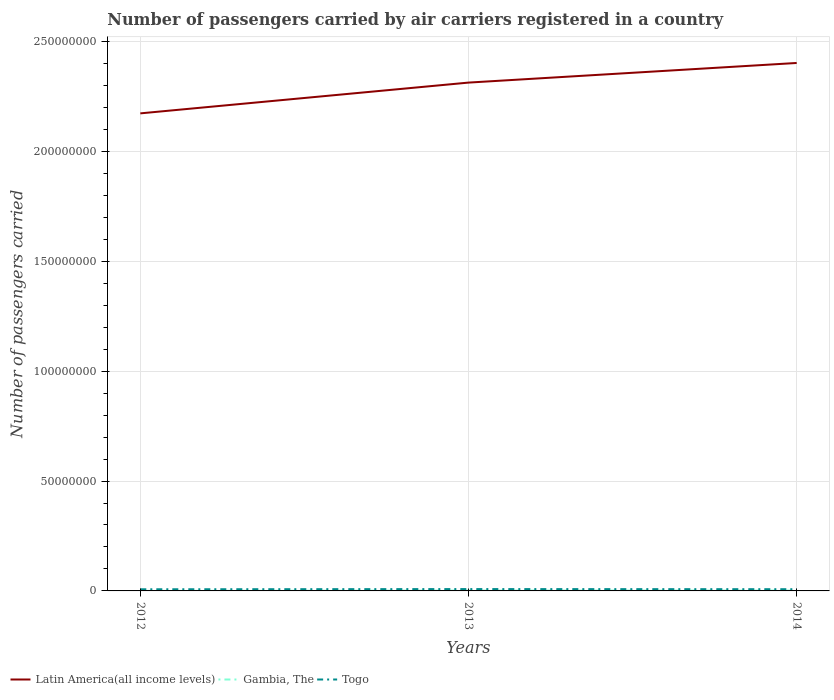How many different coloured lines are there?
Offer a very short reply. 3. Does the line corresponding to Togo intersect with the line corresponding to Gambia, The?
Your answer should be compact. No. Is the number of lines equal to the number of legend labels?
Keep it short and to the point. Yes. Across all years, what is the maximum number of passengers carried by air carriers in Latin America(all income levels)?
Ensure brevity in your answer.  2.17e+08. What is the total number of passengers carried by air carriers in Latin America(all income levels) in the graph?
Provide a succinct answer. -1.40e+07. What is the difference between the highest and the second highest number of passengers carried by air carriers in Togo?
Your response must be concise. 9.52e+04. What is the difference between the highest and the lowest number of passengers carried by air carriers in Gambia, The?
Your answer should be very brief. 2. Is the number of passengers carried by air carriers in Gambia, The strictly greater than the number of passengers carried by air carriers in Togo over the years?
Keep it short and to the point. Yes. How many years are there in the graph?
Make the answer very short. 3. What is the difference between two consecutive major ticks on the Y-axis?
Make the answer very short. 5.00e+07. Are the values on the major ticks of Y-axis written in scientific E-notation?
Ensure brevity in your answer.  No. Where does the legend appear in the graph?
Offer a very short reply. Bottom left. How many legend labels are there?
Make the answer very short. 3. What is the title of the graph?
Make the answer very short. Number of passengers carried by air carriers registered in a country. What is the label or title of the X-axis?
Your response must be concise. Years. What is the label or title of the Y-axis?
Ensure brevity in your answer.  Number of passengers carried. What is the Number of passengers carried of Latin America(all income levels) in 2012?
Your answer should be very brief. 2.17e+08. What is the Number of passengers carried of Gambia, The in 2012?
Give a very brief answer. 1.13e+04. What is the Number of passengers carried of Togo in 2012?
Provide a succinct answer. 7.46e+05. What is the Number of passengers carried in Latin America(all income levels) in 2013?
Your answer should be compact. 2.31e+08. What is the Number of passengers carried of Gambia, The in 2013?
Your answer should be very brief. 1.47e+05. What is the Number of passengers carried in Togo in 2013?
Provide a succinct answer. 8.41e+05. What is the Number of passengers carried of Latin America(all income levels) in 2014?
Give a very brief answer. 2.40e+08. What is the Number of passengers carried in Gambia, The in 2014?
Make the answer very short. 1.52e+05. What is the Number of passengers carried in Togo in 2014?
Offer a terse response. 7.79e+05. Across all years, what is the maximum Number of passengers carried in Latin America(all income levels)?
Your answer should be very brief. 2.40e+08. Across all years, what is the maximum Number of passengers carried of Gambia, The?
Your answer should be very brief. 1.52e+05. Across all years, what is the maximum Number of passengers carried of Togo?
Your answer should be compact. 8.41e+05. Across all years, what is the minimum Number of passengers carried of Latin America(all income levels)?
Offer a terse response. 2.17e+08. Across all years, what is the minimum Number of passengers carried in Gambia, The?
Make the answer very short. 1.13e+04. Across all years, what is the minimum Number of passengers carried in Togo?
Keep it short and to the point. 7.46e+05. What is the total Number of passengers carried of Latin America(all income levels) in the graph?
Make the answer very short. 6.89e+08. What is the total Number of passengers carried of Gambia, The in the graph?
Provide a succinct answer. 3.10e+05. What is the total Number of passengers carried of Togo in the graph?
Ensure brevity in your answer.  2.37e+06. What is the difference between the Number of passengers carried in Latin America(all income levels) in 2012 and that in 2013?
Your answer should be very brief. -1.40e+07. What is the difference between the Number of passengers carried of Gambia, The in 2012 and that in 2013?
Your response must be concise. -1.36e+05. What is the difference between the Number of passengers carried in Togo in 2012 and that in 2013?
Your response must be concise. -9.52e+04. What is the difference between the Number of passengers carried in Latin America(all income levels) in 2012 and that in 2014?
Your response must be concise. -2.29e+07. What is the difference between the Number of passengers carried of Gambia, The in 2012 and that in 2014?
Your answer should be very brief. -1.40e+05. What is the difference between the Number of passengers carried in Togo in 2012 and that in 2014?
Your answer should be compact. -3.35e+04. What is the difference between the Number of passengers carried of Latin America(all income levels) in 2013 and that in 2014?
Your response must be concise. -8.93e+06. What is the difference between the Number of passengers carried of Gambia, The in 2013 and that in 2014?
Keep it short and to the point. -4990.75. What is the difference between the Number of passengers carried of Togo in 2013 and that in 2014?
Ensure brevity in your answer.  6.17e+04. What is the difference between the Number of passengers carried in Latin America(all income levels) in 2012 and the Number of passengers carried in Gambia, The in 2013?
Provide a succinct answer. 2.17e+08. What is the difference between the Number of passengers carried of Latin America(all income levels) in 2012 and the Number of passengers carried of Togo in 2013?
Your answer should be very brief. 2.16e+08. What is the difference between the Number of passengers carried of Gambia, The in 2012 and the Number of passengers carried of Togo in 2013?
Offer a very short reply. -8.30e+05. What is the difference between the Number of passengers carried in Latin America(all income levels) in 2012 and the Number of passengers carried in Gambia, The in 2014?
Your answer should be compact. 2.17e+08. What is the difference between the Number of passengers carried in Latin America(all income levels) in 2012 and the Number of passengers carried in Togo in 2014?
Provide a short and direct response. 2.17e+08. What is the difference between the Number of passengers carried of Gambia, The in 2012 and the Number of passengers carried of Togo in 2014?
Give a very brief answer. -7.68e+05. What is the difference between the Number of passengers carried of Latin America(all income levels) in 2013 and the Number of passengers carried of Gambia, The in 2014?
Ensure brevity in your answer.  2.31e+08. What is the difference between the Number of passengers carried in Latin America(all income levels) in 2013 and the Number of passengers carried in Togo in 2014?
Keep it short and to the point. 2.31e+08. What is the difference between the Number of passengers carried of Gambia, The in 2013 and the Number of passengers carried of Togo in 2014?
Provide a short and direct response. -6.32e+05. What is the average Number of passengers carried of Latin America(all income levels) per year?
Your answer should be compact. 2.30e+08. What is the average Number of passengers carried in Gambia, The per year?
Make the answer very short. 1.03e+05. What is the average Number of passengers carried of Togo per year?
Offer a terse response. 7.89e+05. In the year 2012, what is the difference between the Number of passengers carried of Latin America(all income levels) and Number of passengers carried of Gambia, The?
Provide a succinct answer. 2.17e+08. In the year 2012, what is the difference between the Number of passengers carried of Latin America(all income levels) and Number of passengers carried of Togo?
Your answer should be very brief. 2.17e+08. In the year 2012, what is the difference between the Number of passengers carried of Gambia, The and Number of passengers carried of Togo?
Offer a very short reply. -7.34e+05. In the year 2013, what is the difference between the Number of passengers carried of Latin America(all income levels) and Number of passengers carried of Gambia, The?
Make the answer very short. 2.31e+08. In the year 2013, what is the difference between the Number of passengers carried in Latin America(all income levels) and Number of passengers carried in Togo?
Offer a very short reply. 2.30e+08. In the year 2013, what is the difference between the Number of passengers carried of Gambia, The and Number of passengers carried of Togo?
Your answer should be compact. -6.94e+05. In the year 2014, what is the difference between the Number of passengers carried of Latin America(all income levels) and Number of passengers carried of Gambia, The?
Provide a short and direct response. 2.40e+08. In the year 2014, what is the difference between the Number of passengers carried of Latin America(all income levels) and Number of passengers carried of Togo?
Your answer should be very brief. 2.39e+08. In the year 2014, what is the difference between the Number of passengers carried in Gambia, The and Number of passengers carried in Togo?
Your response must be concise. -6.27e+05. What is the ratio of the Number of passengers carried in Latin America(all income levels) in 2012 to that in 2013?
Offer a very short reply. 0.94. What is the ratio of the Number of passengers carried of Gambia, The in 2012 to that in 2013?
Your answer should be very brief. 0.08. What is the ratio of the Number of passengers carried in Togo in 2012 to that in 2013?
Provide a succinct answer. 0.89. What is the ratio of the Number of passengers carried of Latin America(all income levels) in 2012 to that in 2014?
Give a very brief answer. 0.9. What is the ratio of the Number of passengers carried of Gambia, The in 2012 to that in 2014?
Keep it short and to the point. 0.07. What is the ratio of the Number of passengers carried of Togo in 2012 to that in 2014?
Provide a succinct answer. 0.96. What is the ratio of the Number of passengers carried in Latin America(all income levels) in 2013 to that in 2014?
Make the answer very short. 0.96. What is the ratio of the Number of passengers carried in Gambia, The in 2013 to that in 2014?
Your response must be concise. 0.97. What is the ratio of the Number of passengers carried in Togo in 2013 to that in 2014?
Ensure brevity in your answer.  1.08. What is the difference between the highest and the second highest Number of passengers carried in Latin America(all income levels)?
Offer a terse response. 8.93e+06. What is the difference between the highest and the second highest Number of passengers carried in Gambia, The?
Offer a terse response. 4990.75. What is the difference between the highest and the second highest Number of passengers carried of Togo?
Your response must be concise. 6.17e+04. What is the difference between the highest and the lowest Number of passengers carried of Latin America(all income levels)?
Make the answer very short. 2.29e+07. What is the difference between the highest and the lowest Number of passengers carried of Gambia, The?
Keep it short and to the point. 1.40e+05. What is the difference between the highest and the lowest Number of passengers carried in Togo?
Offer a terse response. 9.52e+04. 